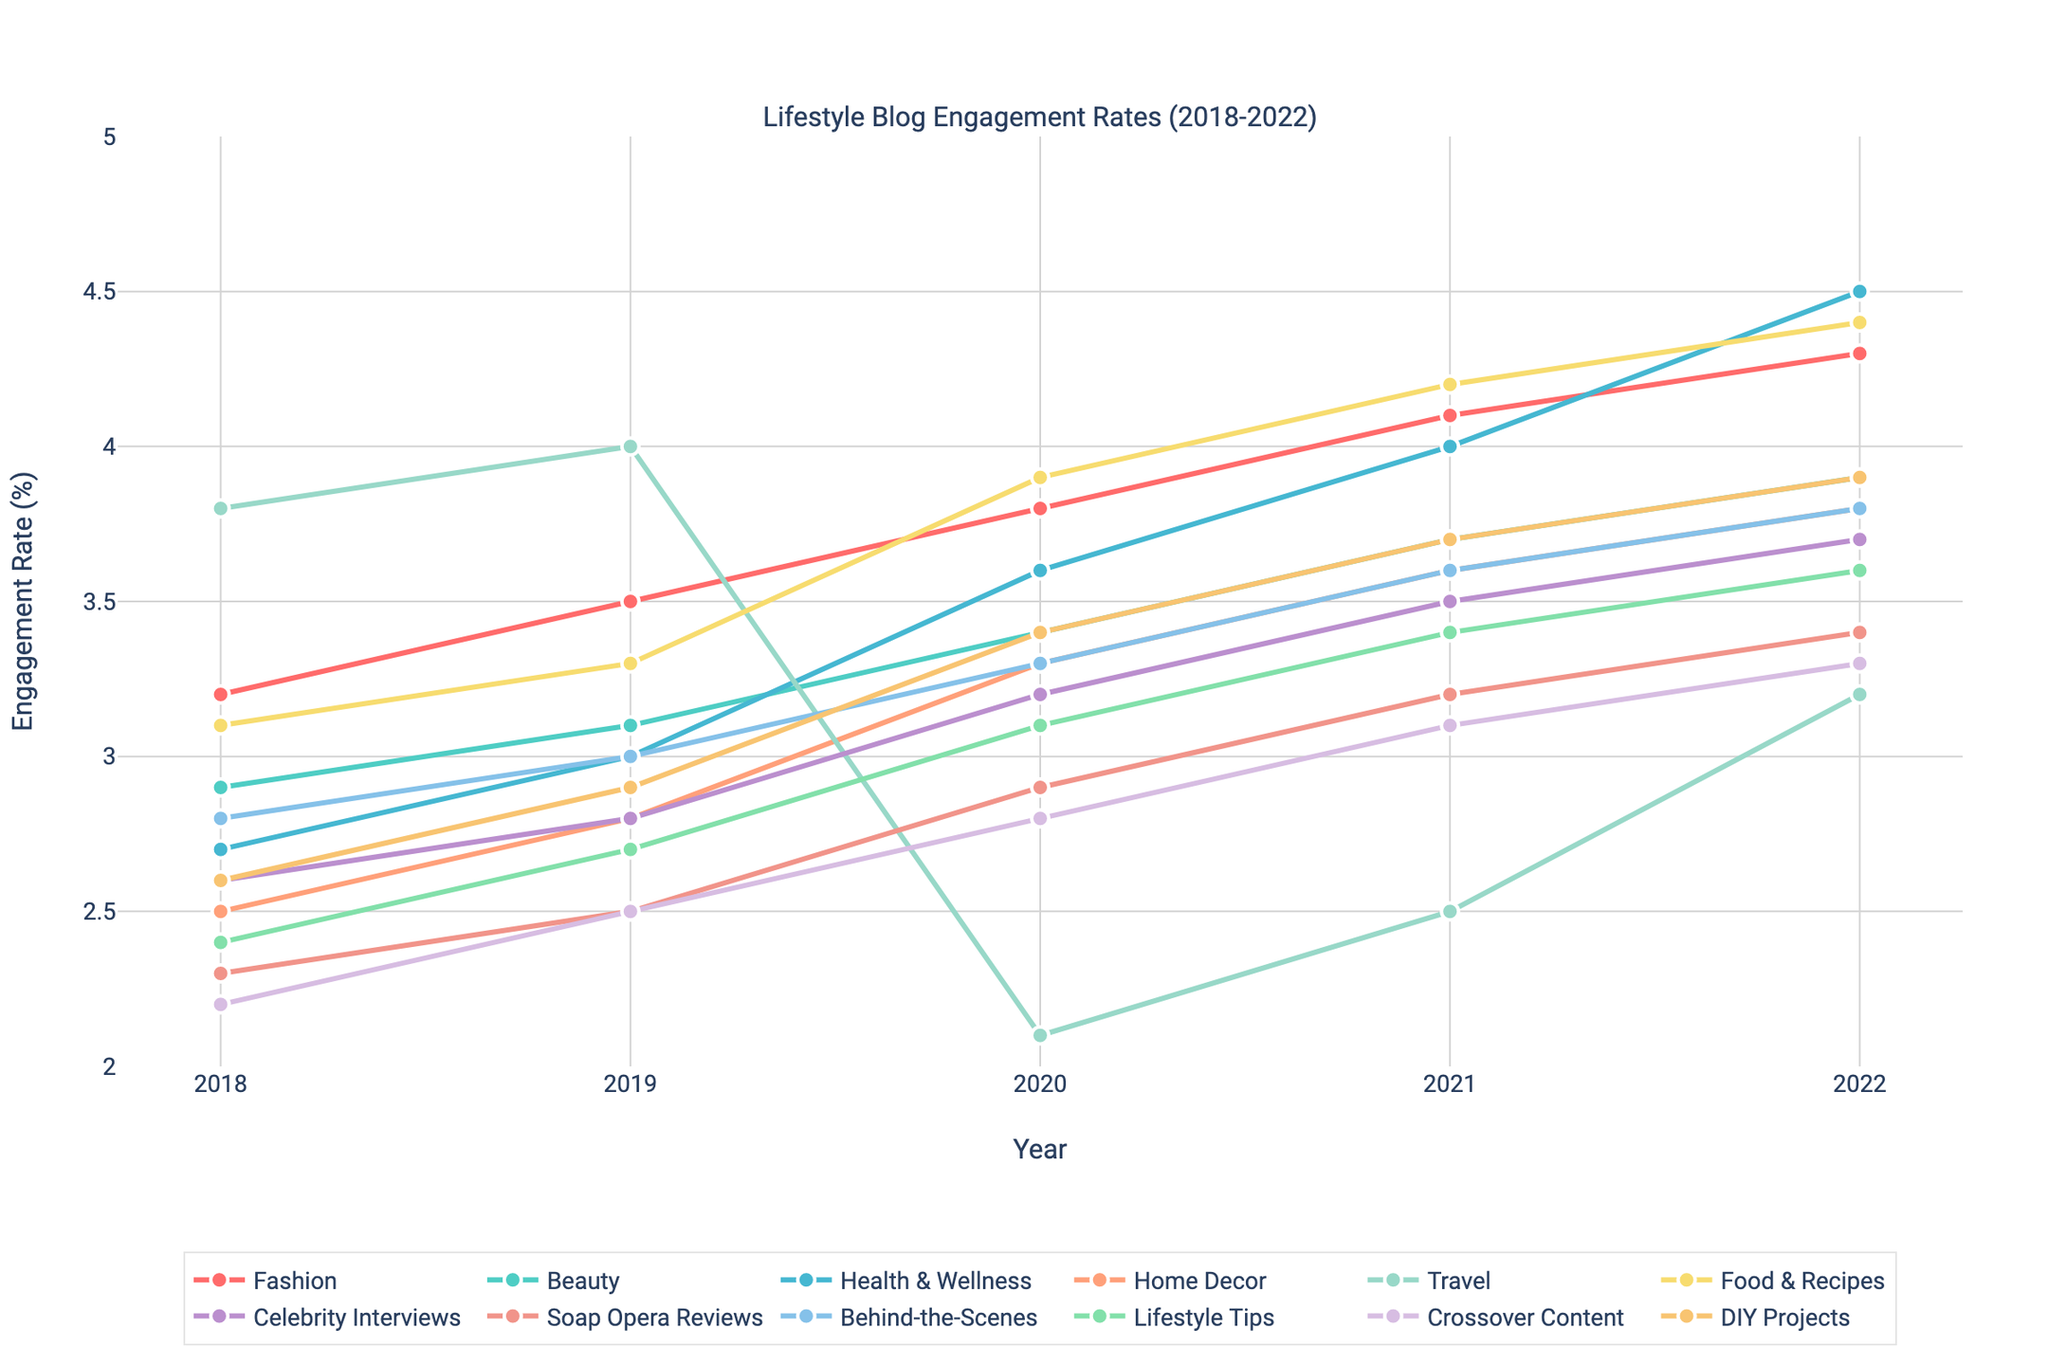What's the overall trend in engagement rates for the 'Fashion' category from 2018 to 2022? The 'Fashion' category shows a consistent increase in engagement rates from 3.2% in 2018 to 4.3% in 2022.
Answer: Consistent increase Which category experienced the highest increase in engagement rates over the 5 years? The 'Health & Wellness' category saw the highest increase in engagement rates, from 2.7% in 2018 to 4.5% in 2022, a total increase of 1.8%.
Answer: Health & Wellness Between 'Celebrity Interviews' and 'Soap Opera Reviews,' which category showed a higher engagement rate in 2021? In 2021, 'Celebrity Interviews' had an engagement rate of 3.5%, whereas 'Soap Opera Reviews' had a rate of 3.2%. Hence, 'Celebrity Interviews' showed a higher engagement rate.
Answer: Celebrity Interviews Which year did 'Travel' see the lowest engagement rate, and what was the rate? The 'Travel' category saw the lowest engagement rate in 2020 with a rate of 2.1%.
Answer: 2020, 2.1% How did the engagement rate of 'Crossover Content' change between 2019 and 2022? The engagement rate of 'Crossover Content' increased from 2.5% in 2019 to 3.3% in 2022, showing a consistent rise.
Answer: Consistent rise In 2019, compare the engagement rates of the 'Food & Recipes' and 'Home Decor' categories. Which one was higher and by how much? In 2019, 'Food & Recipes' had an engagement rate of 3.3%, while 'Home Decor' had a rate of 2.8%. 'Food & Recipes' was higher by 0.5%.
Answer: Food & Recipes, 0.5% What is the average engagement rate of the 'DIY Projects' category over the 5 years? To find the average engagement rate of 'DIY Projects': (2.6 + 2.9 + 3.4 + 3.7 + 3.9) / 5 = 3.3%.
Answer: 3.3% Among all categories in 2020, which had the highest engagement rate and what was the rate? In 2020, 'Food & Recipes' had the highest engagement rate with a rate of 3.9%.
Answer: Food & Recipes, 3.9% By how much did the engagement rate for 'Behind-the-Scenes' grow from 2018 to 2022? The 'Behind-the-Scenes' category grew from 2.8% in 2018 to 3.8% in 2022, showing a growth of 1%.
Answer: 1% Which two categories had the closest engagement rates in 2018, and what were those rates? In 2018, 'Beauty' (2.9%) and 'Food & Recipes' (3.1%) had the closest engagement rates with a difference of only 0.2%.
Answer: Beauty and Food & Recipes, 2.9% and 3.1% 